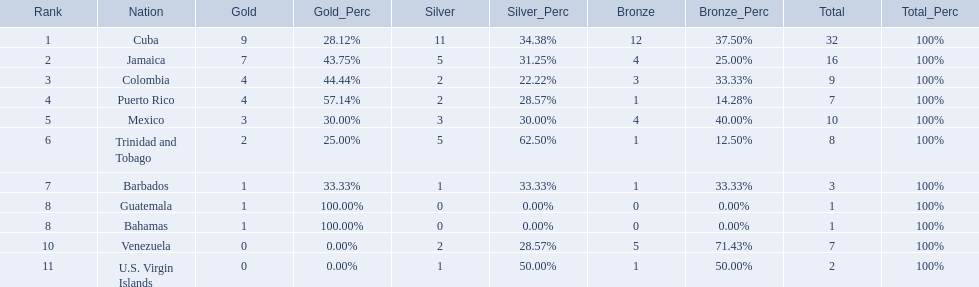Could you parse the entire table? {'header': ['Rank', 'Nation', 'Gold', 'Gold_Perc', 'Silver', 'Silver_Perc', 'Bronze', 'Bronze_Perc', 'Total', 'Total_Perc'], 'rows': [['1', 'Cuba', '9', '28.12%', '11', '34.38%', '12', '37.50%', '32', '100%'], ['2', 'Jamaica', '7', '43.75%', '5', '31.25%', '4', '25.00%', '16', '100%'], ['3', 'Colombia', '4', '44.44%', '2', '22.22%', '3', '33.33%', '9', '100%'], ['4', 'Puerto Rico', '4', '57.14%', '2', '28.57%', '1', '14.28%', '7', '100%'], ['5', 'Mexico', '3', '30.00%', '3', '30.00%', '4', '40.00%', '10', '100%'], ['6', 'Trinidad and Tobago', '2', '25.00%', '5', '62.50%', '1', '12.50%', '8', '100%'], ['7', 'Barbados', '1', '33.33%', '1', '33.33%', '1', '33.33%', '3', '100%'], ['8', 'Guatemala', '1', '100.00%', '0', '0.00%', '0', '0.00%', '1', '100%'], ['8', 'Bahamas', '1', '100.00%', '0', '0.00%', '0', '0.00%', '1', '100%'], ['10', 'Venezuela', '0', '0.00%', '2', '28.57%', '5', '71.43%', '7', '100%'], ['11', 'U.S. Virgin Islands', '0', '0.00%', '1', '50.00%', '1', '50.00%', '2', '100%']]} Which teams have at exactly 4 gold medals? Colombia, Puerto Rico. Of those teams which has exactly 1 bronze medal? Puerto Rico. 